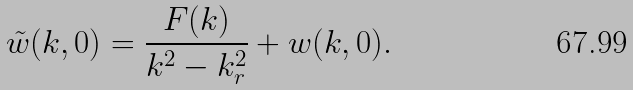<formula> <loc_0><loc_0><loc_500><loc_500>\tilde { w } ( k , 0 ) = \frac { F ( k ) } { k ^ { 2 } - k _ { r } ^ { 2 } } + w ( k , 0 ) .</formula> 